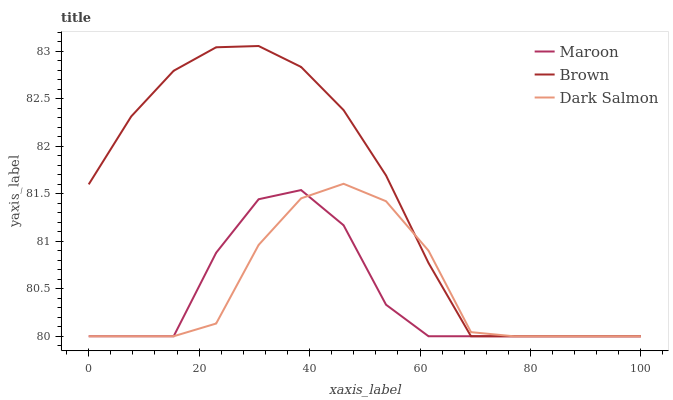Does Maroon have the minimum area under the curve?
Answer yes or no. Yes. Does Brown have the maximum area under the curve?
Answer yes or no. Yes. Does Dark Salmon have the minimum area under the curve?
Answer yes or no. No. Does Dark Salmon have the maximum area under the curve?
Answer yes or no. No. Is Brown the smoothest?
Answer yes or no. Yes. Is Maroon the roughest?
Answer yes or no. Yes. Is Dark Salmon the smoothest?
Answer yes or no. No. Is Dark Salmon the roughest?
Answer yes or no. No. Does Dark Salmon have the highest value?
Answer yes or no. No. 